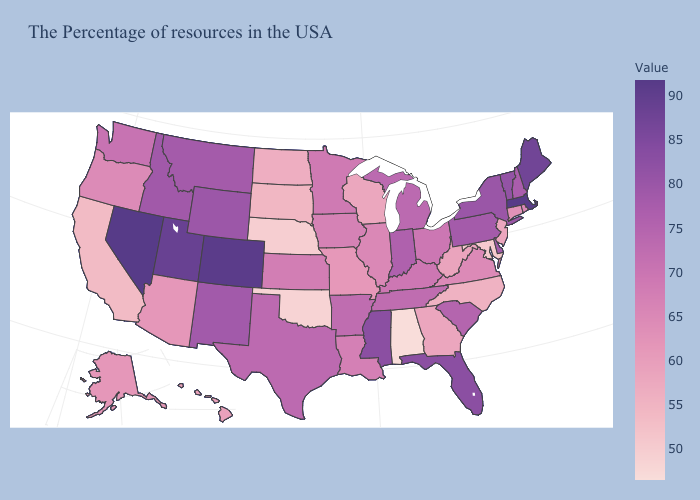Does Nevada have the highest value in the USA?
Answer briefly. Yes. Among the states that border Louisiana , which have the lowest value?
Concise answer only. Arkansas. Does California have the lowest value in the West?
Keep it brief. Yes. Among the states that border Wisconsin , which have the lowest value?
Give a very brief answer. Illinois. Among the states that border Rhode Island , does Connecticut have the lowest value?
Write a very short answer. Yes. Which states have the highest value in the USA?
Short answer required. Nevada. Among the states that border North Dakota , does Minnesota have the lowest value?
Write a very short answer. No. 